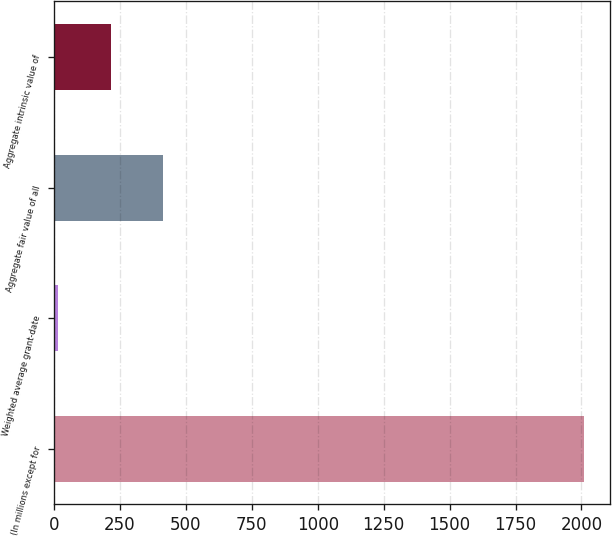Convert chart to OTSL. <chart><loc_0><loc_0><loc_500><loc_500><bar_chart><fcel>(In millions except for<fcel>Weighted average grant-date<fcel>Aggregate fair value of all<fcel>Aggregate intrinsic value of<nl><fcel>2009<fcel>14.91<fcel>413.73<fcel>214.32<nl></chart> 